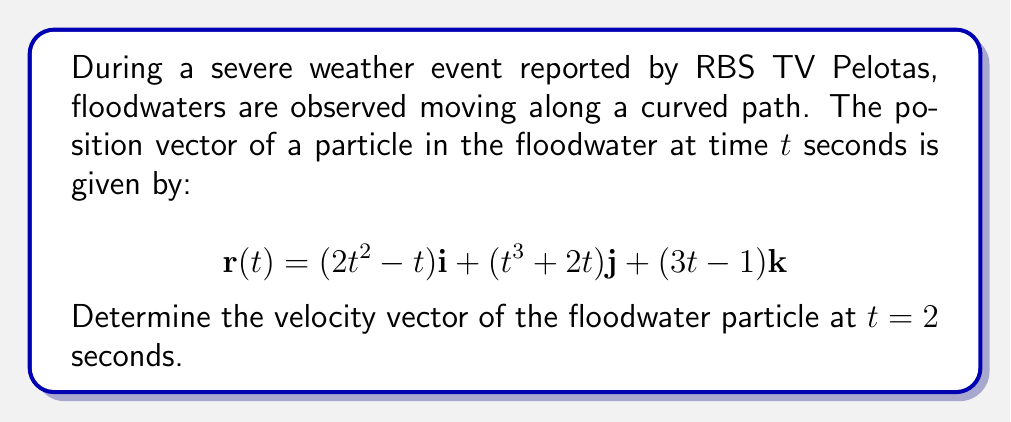Teach me how to tackle this problem. To find the velocity vector, we need to differentiate the position vector with respect to time. The velocity vector is given by:

$$\mathbf{v}(t) = \frac{d\mathbf{r}}{dt}$$

Let's differentiate each component:

1. For the i-component:
   $$\frac{d}{dt}(2t^2 - t) = 4t - 1$$

2. For the j-component:
   $$\frac{d}{dt}(t^3 + 2t) = 3t^2 + 2$$

3. For the k-component:
   $$\frac{d}{dt}(3t - 1) = 3$$

Therefore, the velocity vector is:

$$\mathbf{v}(t) = (4t - 1)\mathbf{i} + (3t^2 + 2)\mathbf{j} + 3\mathbf{k}$$

To find the velocity at $t = 2$ seconds, we substitute $t = 2$ into this expression:

$$\begin{align*}
\mathbf{v}(2) &= (4(2) - 1)\mathbf{i} + (3(2)^2 + 2)\mathbf{j} + 3\mathbf{k} \\
&= 7\mathbf{i} + 14\mathbf{j} + 3\mathbf{k}
\end{align*}$$
Answer: The velocity vector of the floodwater particle at $t = 2$ seconds is $7\mathbf{i} + 14\mathbf{j} + 3\mathbf{k}$ m/s. 